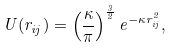<formula> <loc_0><loc_0><loc_500><loc_500>U ( r _ { i j } ) = \left ( \frac { \kappa } { \pi } \right ) ^ { \frac { 3 } { 2 } } e ^ { - \kappa r ^ { 2 } _ { i j } } ,</formula> 